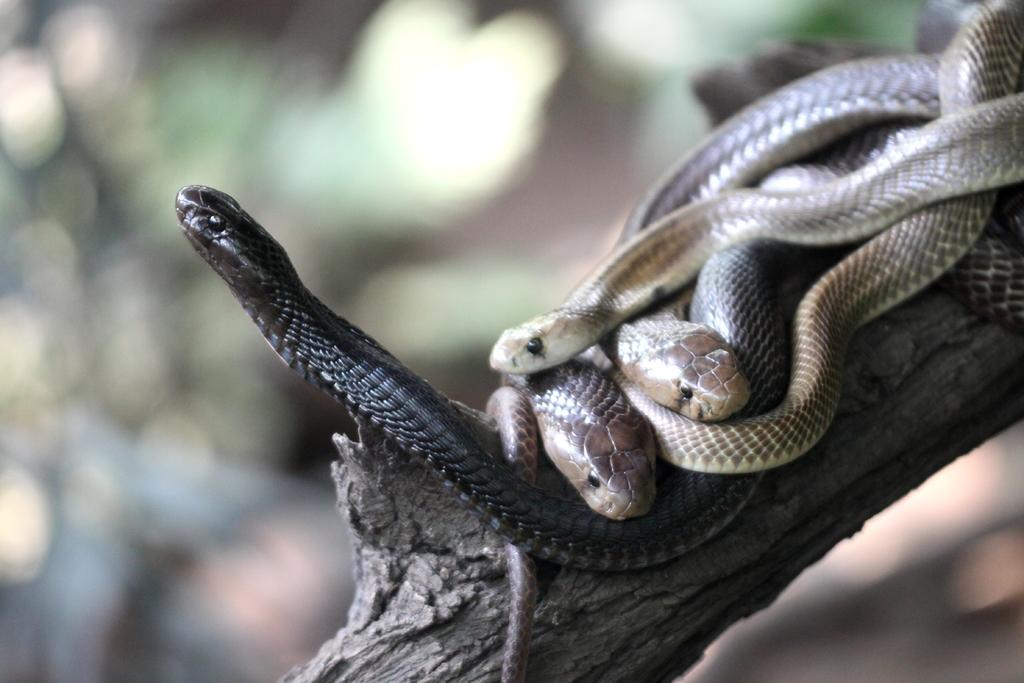What animals are on the wooden branch in the image? There are snakes on a wooden branch in the image. Can you describe the background of the image? The background of the image is blurred. What type of chicken can be seen in the image? There is no chicken present in the image; it features snakes on a wooden branch. What form does the brass take in the image? There is no brass present in the image. 